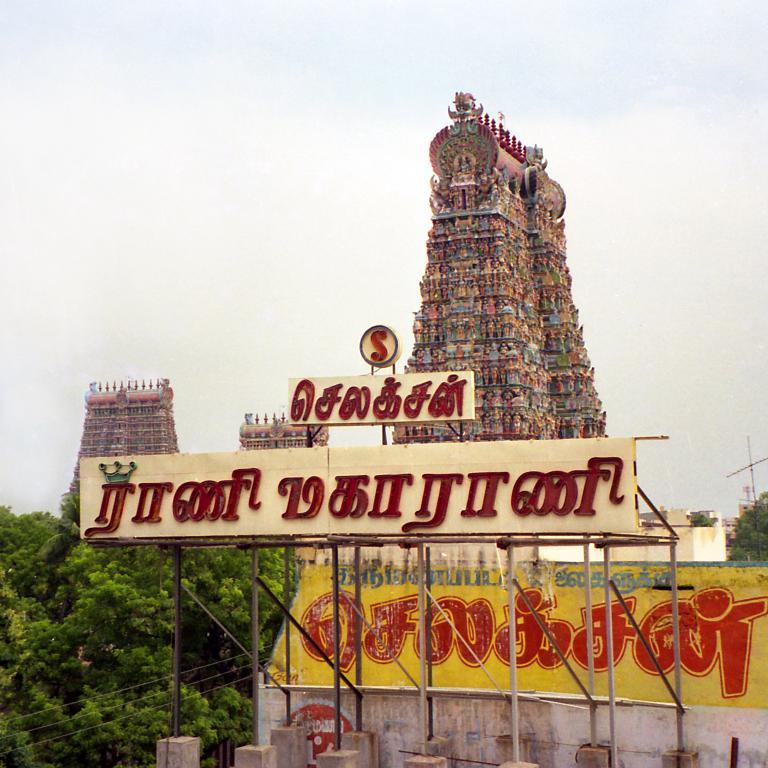What type of structures can be seen in the image? There are temples in the image. What are the name boards used for in the image? The name boards are used to identify the temples or other structures in the image. What type of poles are visible in the image? Iron poles are visible in the image. What is present in the image that might be used for transmitting electricity or communication signals? Cables are present in the image. What type of man-made structures are visible in the image? There are buildings in the image. What type of natural vegetation is visible in the image? Trees are visible in the image. What part of the natural environment is visible in the image? The sky is visible in the image. What type of weather can be inferred from the image? Clouds are present in the sky, suggesting that it might be a partly cloudy day. What type of comb is used by the trees in the image? There is no comb present in the image, as trees do not use combs. What type of collar is visible on the clouds in the image? There is no collar present in the image, as clouds do not have collars. 